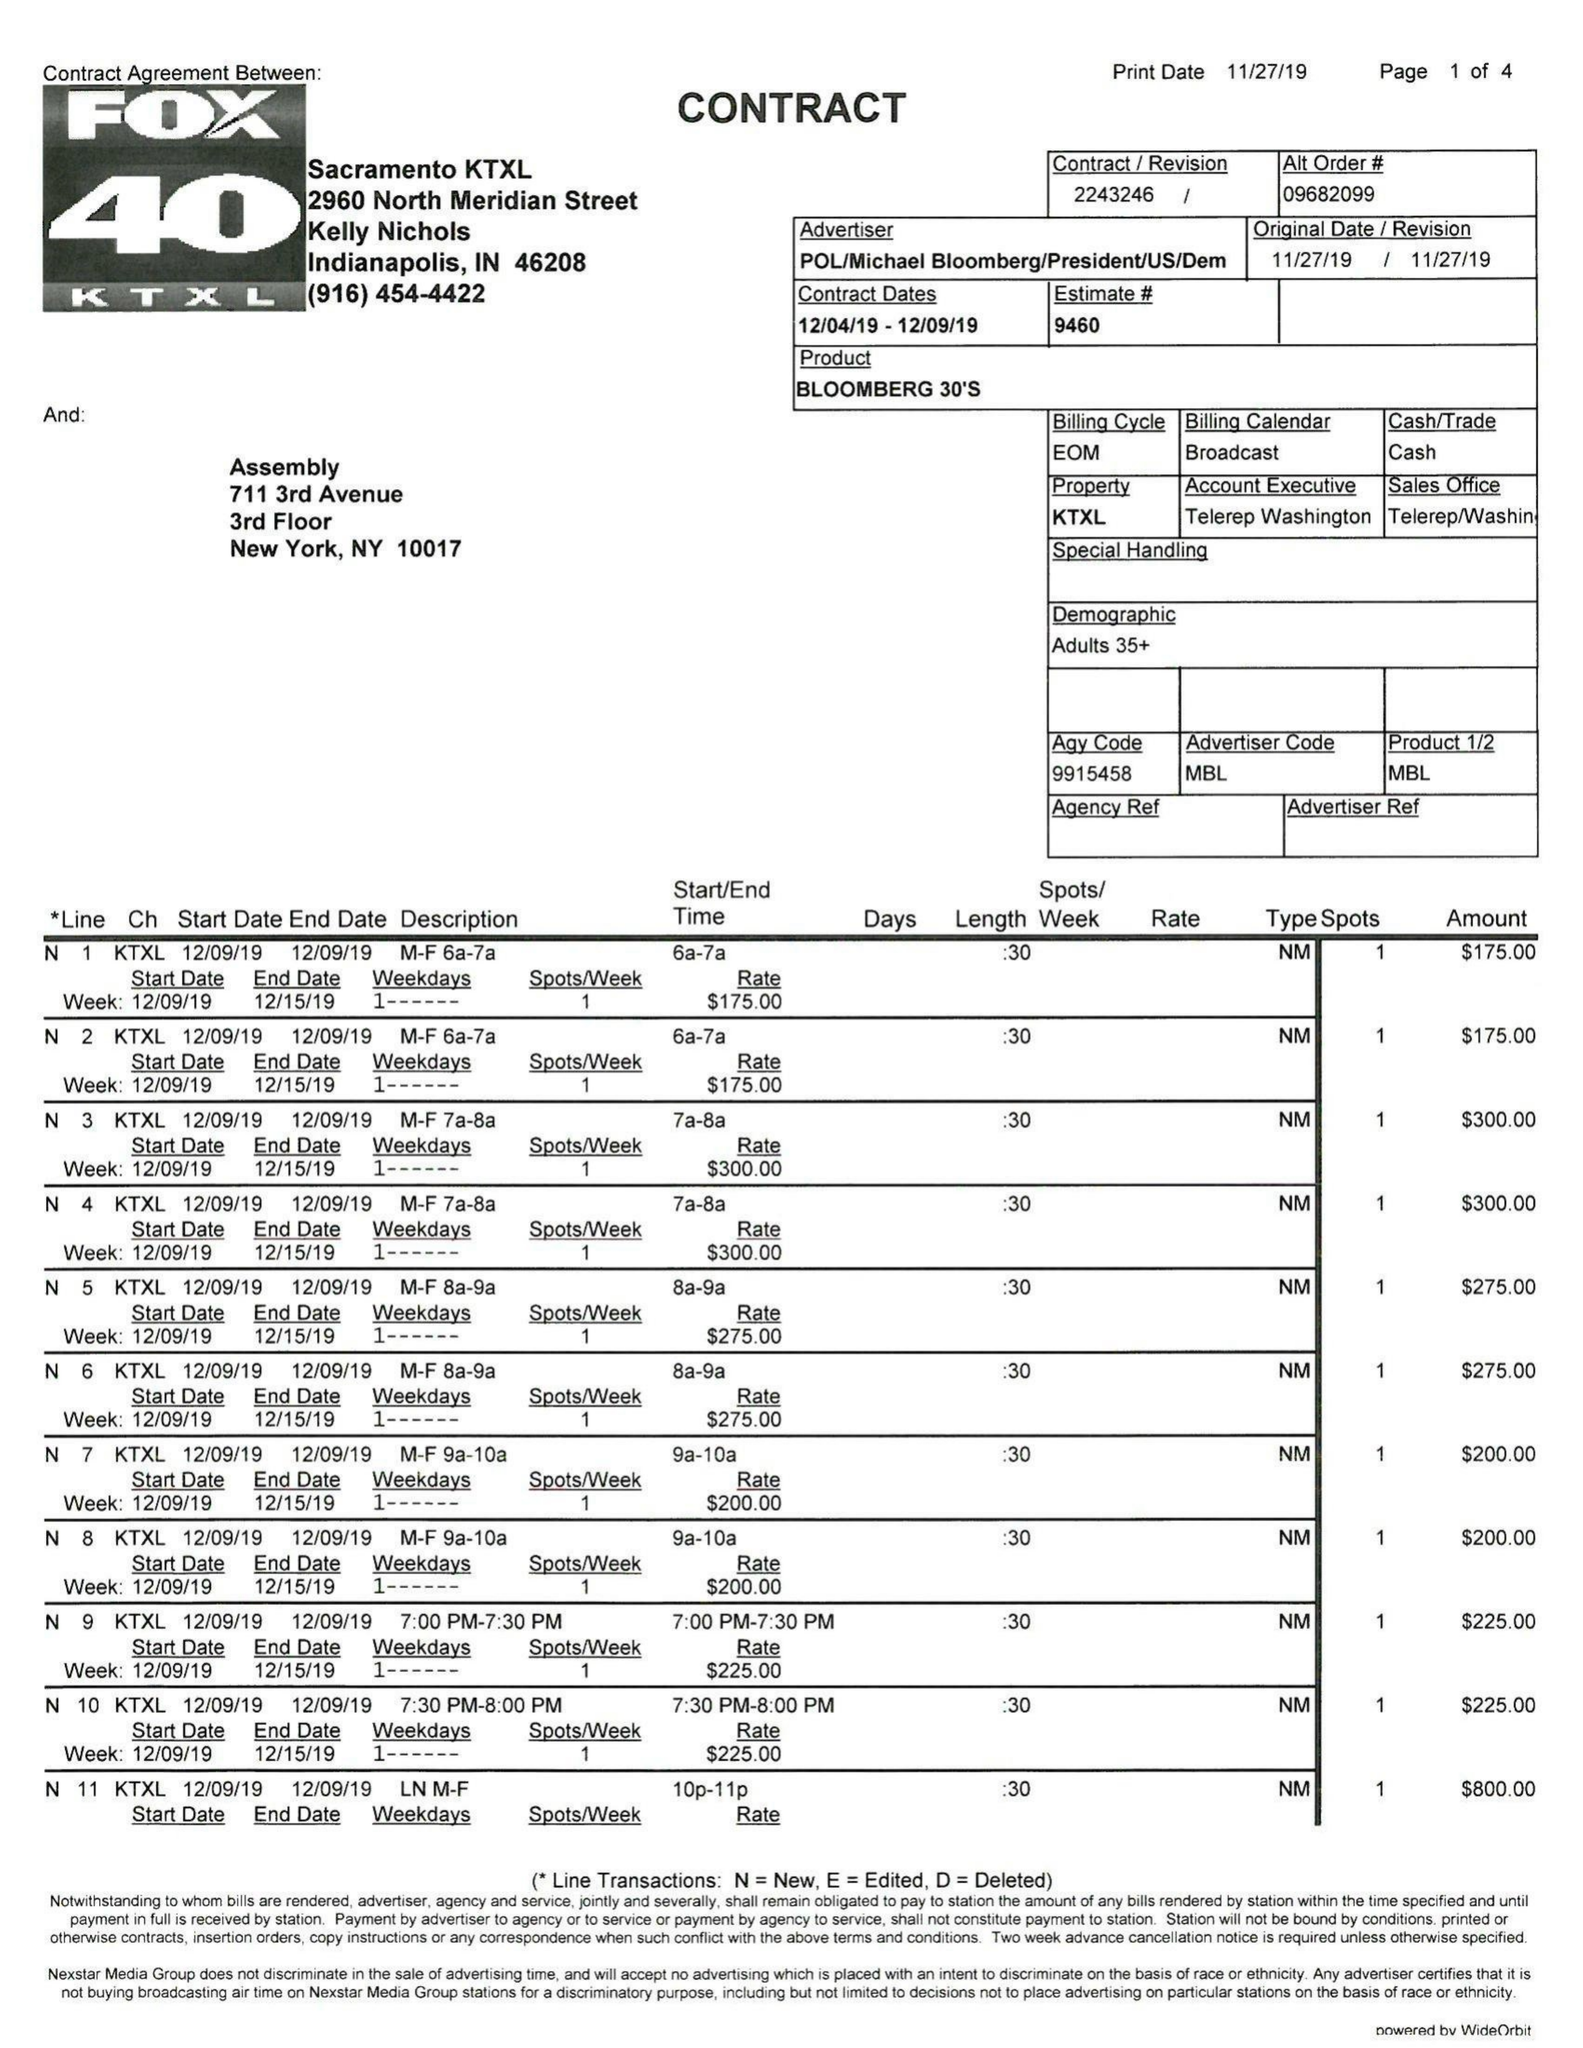What is the value for the flight_to?
Answer the question using a single word or phrase. 12/09/19 